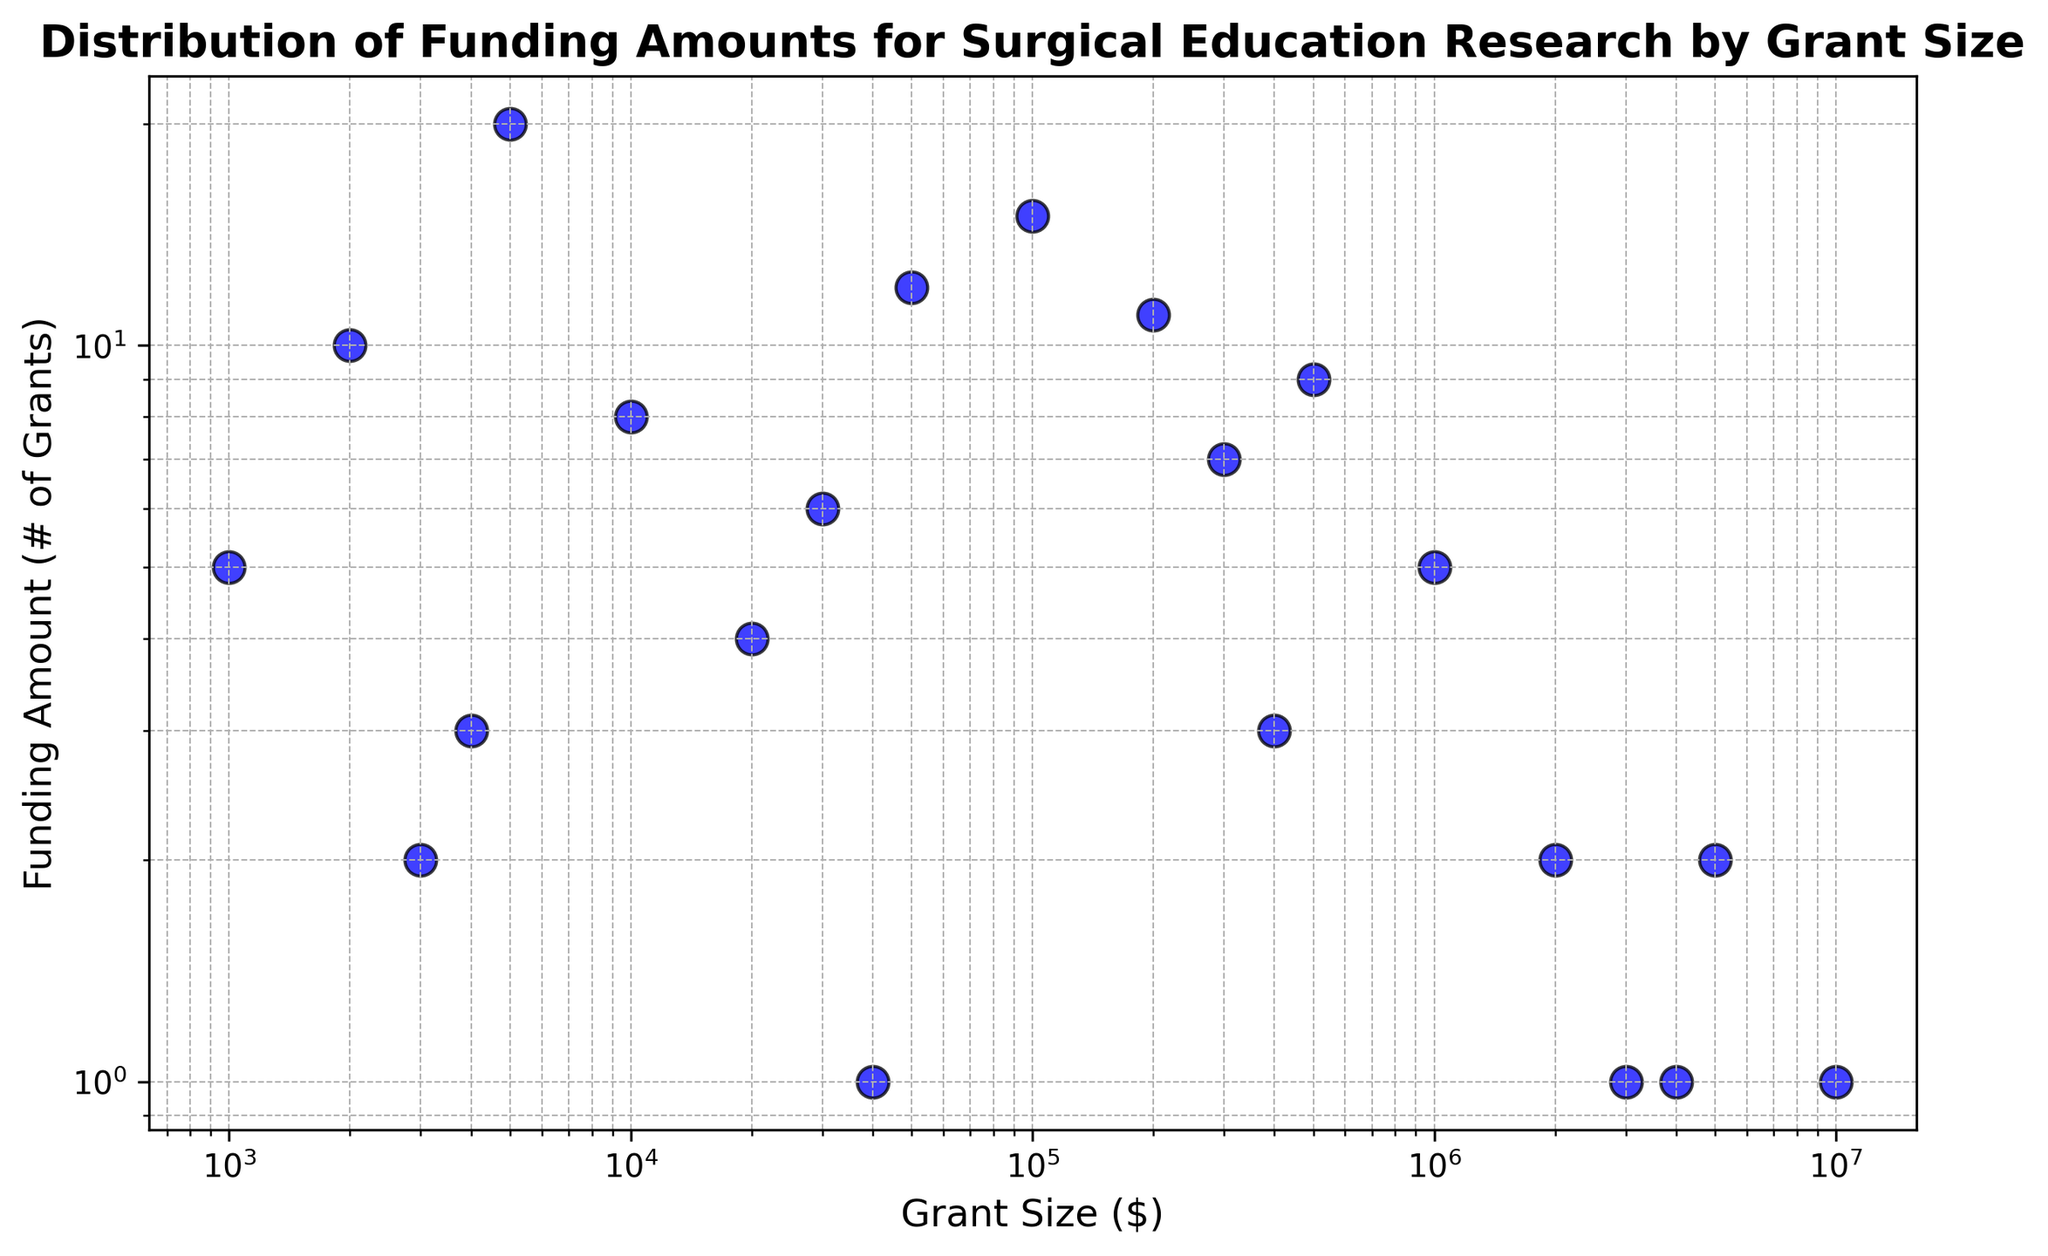What is the funding amount for a grant size of $10,000? Look for the point on the figure where the grant size is $10,000 and note the corresponding funding amount on the y-axis.
Answer: 8 Is there a grant size category that has the equal funding amount as the $5000 grant size category? Verify the funding amount for the $5000 grant size category (20), then look for another data point on the graph with the same y-coordinate.
Answer: No What is the sum of funding amounts for grant sizes $500,000 and $1,000,000? Find the funding amounts for grant sizes $500,000 (9) and $1,000,000 (5) and add them together (9 + 5).
Answer: 14 Which grant size category has the highest funding amount? Identify the data point with the highest position along the y-axis corresponding to the funding amount.
Answer: 5000 How many grant size categories have a funding amount of less than 5? Count the number of data points where their y-coordinates are below 5 on the graph.
Answer: 7 Is there a visible trend in funding amounts as grant sizes increase? Look at the overall distribution of the points; observe if there's any apparent clustering or pattern as you move along the x-axis.
Answer: Yes, generally funding decreases as grant sizes increase Which grant size category has a higher funding amount: $100,000 or $200,000? Check the funding amounts for both $100,000 (15) and $200,000 (11) and compare them.
Answer: 100000 How many grant size categories have a funding amount of at least 10? Count all the points on the graph which have y-coordinates equal to or greater than 10.
Answer: 6 What is the difference in funding amounts between the $50,000 and $100,000 grant sizes? Find the funding amounts for $50,000 (12) and $100,000 (15) and subtract to find the difference (15 - 12).
Answer: 3 